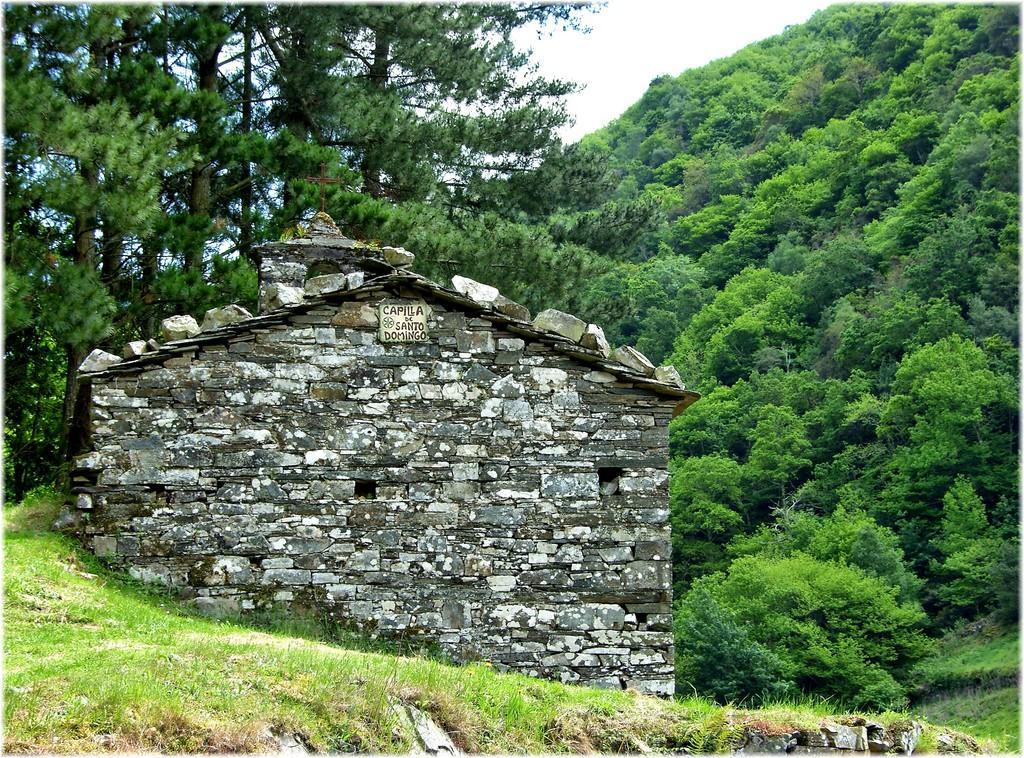In one or two sentences, can you explain what this image depicts? In this image I see the wall which is made of stones and I see a board over here on which there are few words written and I see the green grass. In the background I see the trees and the sky. 